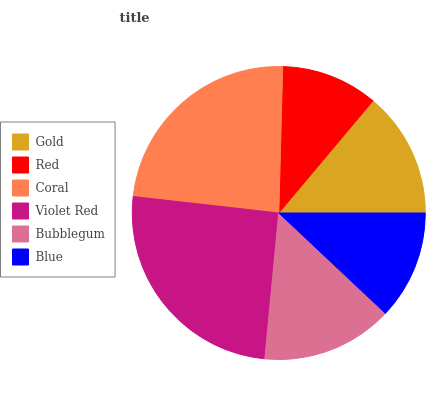Is Red the minimum?
Answer yes or no. Yes. Is Violet Red the maximum?
Answer yes or no. Yes. Is Coral the minimum?
Answer yes or no. No. Is Coral the maximum?
Answer yes or no. No. Is Coral greater than Red?
Answer yes or no. Yes. Is Red less than Coral?
Answer yes or no. Yes. Is Red greater than Coral?
Answer yes or no. No. Is Coral less than Red?
Answer yes or no. No. Is Bubblegum the high median?
Answer yes or no. Yes. Is Gold the low median?
Answer yes or no. Yes. Is Red the high median?
Answer yes or no. No. Is Violet Red the low median?
Answer yes or no. No. 